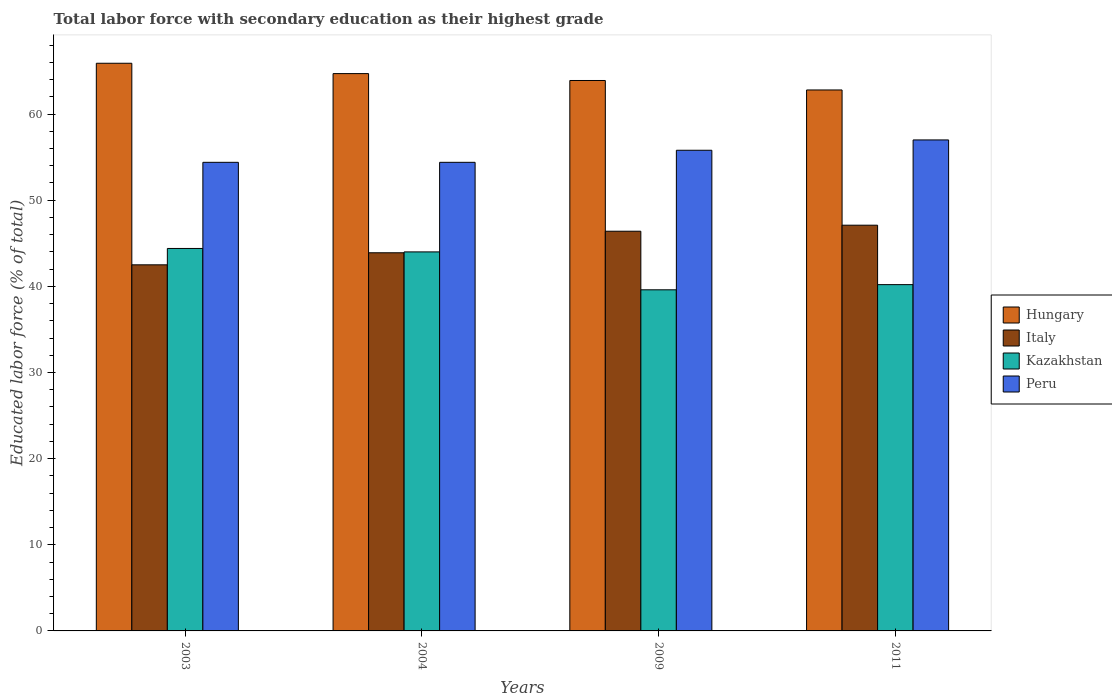How many different coloured bars are there?
Your response must be concise. 4. Are the number of bars on each tick of the X-axis equal?
Provide a short and direct response. Yes. How many bars are there on the 2nd tick from the right?
Your response must be concise. 4. What is the label of the 2nd group of bars from the left?
Your answer should be compact. 2004. What is the percentage of total labor force with primary education in Kazakhstan in 2009?
Your answer should be compact. 39.6. Across all years, what is the minimum percentage of total labor force with primary education in Peru?
Your response must be concise. 54.4. In which year was the percentage of total labor force with primary education in Peru maximum?
Your answer should be very brief. 2011. In which year was the percentage of total labor force with primary education in Italy minimum?
Make the answer very short. 2003. What is the total percentage of total labor force with primary education in Peru in the graph?
Make the answer very short. 221.6. What is the difference between the percentage of total labor force with primary education in Italy in 2004 and that in 2009?
Ensure brevity in your answer.  -2.5. What is the difference between the percentage of total labor force with primary education in Peru in 2011 and the percentage of total labor force with primary education in Hungary in 2003?
Your answer should be very brief. -8.9. What is the average percentage of total labor force with primary education in Peru per year?
Your answer should be very brief. 55.4. In how many years, is the percentage of total labor force with primary education in Peru greater than 32 %?
Provide a succinct answer. 4. What is the ratio of the percentage of total labor force with primary education in Italy in 2003 to that in 2011?
Your response must be concise. 0.9. Is the percentage of total labor force with primary education in Italy in 2003 less than that in 2011?
Your answer should be compact. Yes. What is the difference between the highest and the second highest percentage of total labor force with primary education in Italy?
Offer a terse response. 0.7. What is the difference between the highest and the lowest percentage of total labor force with primary education in Peru?
Your answer should be compact. 2.6. Is it the case that in every year, the sum of the percentage of total labor force with primary education in Hungary and percentage of total labor force with primary education in Kazakhstan is greater than the sum of percentage of total labor force with primary education in Peru and percentage of total labor force with primary education in Italy?
Make the answer very short. Yes. What does the 1st bar from the left in 2009 represents?
Your answer should be compact. Hungary. What does the 2nd bar from the right in 2003 represents?
Keep it short and to the point. Kazakhstan. Are all the bars in the graph horizontal?
Provide a short and direct response. No. How many years are there in the graph?
Keep it short and to the point. 4. Are the values on the major ticks of Y-axis written in scientific E-notation?
Keep it short and to the point. No. Where does the legend appear in the graph?
Give a very brief answer. Center right. How many legend labels are there?
Keep it short and to the point. 4. How are the legend labels stacked?
Your response must be concise. Vertical. What is the title of the graph?
Keep it short and to the point. Total labor force with secondary education as their highest grade. What is the label or title of the Y-axis?
Keep it short and to the point. Educated labor force (% of total). What is the Educated labor force (% of total) in Hungary in 2003?
Your answer should be very brief. 65.9. What is the Educated labor force (% of total) in Italy in 2003?
Offer a terse response. 42.5. What is the Educated labor force (% of total) of Kazakhstan in 2003?
Your response must be concise. 44.4. What is the Educated labor force (% of total) of Peru in 2003?
Your answer should be compact. 54.4. What is the Educated labor force (% of total) in Hungary in 2004?
Offer a very short reply. 64.7. What is the Educated labor force (% of total) of Italy in 2004?
Provide a short and direct response. 43.9. What is the Educated labor force (% of total) in Peru in 2004?
Your answer should be compact. 54.4. What is the Educated labor force (% of total) of Hungary in 2009?
Provide a succinct answer. 63.9. What is the Educated labor force (% of total) in Italy in 2009?
Ensure brevity in your answer.  46.4. What is the Educated labor force (% of total) in Kazakhstan in 2009?
Keep it short and to the point. 39.6. What is the Educated labor force (% of total) in Peru in 2009?
Ensure brevity in your answer.  55.8. What is the Educated labor force (% of total) in Hungary in 2011?
Keep it short and to the point. 62.8. What is the Educated labor force (% of total) of Italy in 2011?
Give a very brief answer. 47.1. What is the Educated labor force (% of total) of Kazakhstan in 2011?
Your response must be concise. 40.2. What is the Educated labor force (% of total) of Peru in 2011?
Your response must be concise. 57. Across all years, what is the maximum Educated labor force (% of total) in Hungary?
Offer a very short reply. 65.9. Across all years, what is the maximum Educated labor force (% of total) in Italy?
Your answer should be very brief. 47.1. Across all years, what is the maximum Educated labor force (% of total) in Kazakhstan?
Your answer should be compact. 44.4. Across all years, what is the minimum Educated labor force (% of total) in Hungary?
Ensure brevity in your answer.  62.8. Across all years, what is the minimum Educated labor force (% of total) in Italy?
Give a very brief answer. 42.5. Across all years, what is the minimum Educated labor force (% of total) in Kazakhstan?
Your answer should be very brief. 39.6. Across all years, what is the minimum Educated labor force (% of total) in Peru?
Your answer should be compact. 54.4. What is the total Educated labor force (% of total) in Hungary in the graph?
Ensure brevity in your answer.  257.3. What is the total Educated labor force (% of total) of Italy in the graph?
Make the answer very short. 179.9. What is the total Educated labor force (% of total) of Kazakhstan in the graph?
Offer a very short reply. 168.2. What is the total Educated labor force (% of total) in Peru in the graph?
Offer a terse response. 221.6. What is the difference between the Educated labor force (% of total) in Hungary in 2003 and that in 2004?
Provide a succinct answer. 1.2. What is the difference between the Educated labor force (% of total) in Italy in 2003 and that in 2004?
Provide a succinct answer. -1.4. What is the difference between the Educated labor force (% of total) of Kazakhstan in 2003 and that in 2004?
Give a very brief answer. 0.4. What is the difference between the Educated labor force (% of total) of Hungary in 2003 and that in 2009?
Make the answer very short. 2. What is the difference between the Educated labor force (% of total) in Italy in 2003 and that in 2009?
Your response must be concise. -3.9. What is the difference between the Educated labor force (% of total) of Peru in 2003 and that in 2009?
Your response must be concise. -1.4. What is the difference between the Educated labor force (% of total) of Hungary in 2003 and that in 2011?
Offer a terse response. 3.1. What is the difference between the Educated labor force (% of total) in Hungary in 2004 and that in 2009?
Offer a terse response. 0.8. What is the difference between the Educated labor force (% of total) of Kazakhstan in 2004 and that in 2009?
Give a very brief answer. 4.4. What is the difference between the Educated labor force (% of total) of Hungary in 2004 and that in 2011?
Offer a terse response. 1.9. What is the difference between the Educated labor force (% of total) in Italy in 2004 and that in 2011?
Ensure brevity in your answer.  -3.2. What is the difference between the Educated labor force (% of total) of Kazakhstan in 2004 and that in 2011?
Give a very brief answer. 3.8. What is the difference between the Educated labor force (% of total) in Hungary in 2009 and that in 2011?
Ensure brevity in your answer.  1.1. What is the difference between the Educated labor force (% of total) in Kazakhstan in 2009 and that in 2011?
Your answer should be very brief. -0.6. What is the difference between the Educated labor force (% of total) in Hungary in 2003 and the Educated labor force (% of total) in Italy in 2004?
Offer a very short reply. 22. What is the difference between the Educated labor force (% of total) of Hungary in 2003 and the Educated labor force (% of total) of Kazakhstan in 2004?
Your response must be concise. 21.9. What is the difference between the Educated labor force (% of total) in Hungary in 2003 and the Educated labor force (% of total) in Peru in 2004?
Offer a terse response. 11.5. What is the difference between the Educated labor force (% of total) in Italy in 2003 and the Educated labor force (% of total) in Peru in 2004?
Offer a terse response. -11.9. What is the difference between the Educated labor force (% of total) of Hungary in 2003 and the Educated labor force (% of total) of Kazakhstan in 2009?
Ensure brevity in your answer.  26.3. What is the difference between the Educated labor force (% of total) in Hungary in 2003 and the Educated labor force (% of total) in Peru in 2009?
Ensure brevity in your answer.  10.1. What is the difference between the Educated labor force (% of total) of Italy in 2003 and the Educated labor force (% of total) of Kazakhstan in 2009?
Provide a succinct answer. 2.9. What is the difference between the Educated labor force (% of total) of Kazakhstan in 2003 and the Educated labor force (% of total) of Peru in 2009?
Ensure brevity in your answer.  -11.4. What is the difference between the Educated labor force (% of total) of Hungary in 2003 and the Educated labor force (% of total) of Italy in 2011?
Your answer should be compact. 18.8. What is the difference between the Educated labor force (% of total) in Hungary in 2003 and the Educated labor force (% of total) in Kazakhstan in 2011?
Make the answer very short. 25.7. What is the difference between the Educated labor force (% of total) in Hungary in 2003 and the Educated labor force (% of total) in Peru in 2011?
Give a very brief answer. 8.9. What is the difference between the Educated labor force (% of total) in Hungary in 2004 and the Educated labor force (% of total) in Italy in 2009?
Make the answer very short. 18.3. What is the difference between the Educated labor force (% of total) in Hungary in 2004 and the Educated labor force (% of total) in Kazakhstan in 2009?
Your answer should be compact. 25.1. What is the difference between the Educated labor force (% of total) of Italy in 2004 and the Educated labor force (% of total) of Kazakhstan in 2009?
Keep it short and to the point. 4.3. What is the difference between the Educated labor force (% of total) of Italy in 2004 and the Educated labor force (% of total) of Peru in 2009?
Your answer should be compact. -11.9. What is the difference between the Educated labor force (% of total) of Kazakhstan in 2004 and the Educated labor force (% of total) of Peru in 2009?
Provide a short and direct response. -11.8. What is the difference between the Educated labor force (% of total) in Hungary in 2004 and the Educated labor force (% of total) in Italy in 2011?
Your answer should be compact. 17.6. What is the difference between the Educated labor force (% of total) in Italy in 2004 and the Educated labor force (% of total) in Kazakhstan in 2011?
Your answer should be compact. 3.7. What is the difference between the Educated labor force (% of total) of Italy in 2004 and the Educated labor force (% of total) of Peru in 2011?
Keep it short and to the point. -13.1. What is the difference between the Educated labor force (% of total) in Hungary in 2009 and the Educated labor force (% of total) in Kazakhstan in 2011?
Your answer should be very brief. 23.7. What is the difference between the Educated labor force (% of total) in Hungary in 2009 and the Educated labor force (% of total) in Peru in 2011?
Your answer should be compact. 6.9. What is the difference between the Educated labor force (% of total) of Kazakhstan in 2009 and the Educated labor force (% of total) of Peru in 2011?
Offer a terse response. -17.4. What is the average Educated labor force (% of total) of Hungary per year?
Your answer should be compact. 64.33. What is the average Educated labor force (% of total) in Italy per year?
Offer a terse response. 44.98. What is the average Educated labor force (% of total) of Kazakhstan per year?
Offer a very short reply. 42.05. What is the average Educated labor force (% of total) in Peru per year?
Your answer should be very brief. 55.4. In the year 2003, what is the difference between the Educated labor force (% of total) in Hungary and Educated labor force (% of total) in Italy?
Provide a short and direct response. 23.4. In the year 2003, what is the difference between the Educated labor force (% of total) in Hungary and Educated labor force (% of total) in Kazakhstan?
Provide a succinct answer. 21.5. In the year 2003, what is the difference between the Educated labor force (% of total) in Hungary and Educated labor force (% of total) in Peru?
Keep it short and to the point. 11.5. In the year 2003, what is the difference between the Educated labor force (% of total) of Italy and Educated labor force (% of total) of Kazakhstan?
Make the answer very short. -1.9. In the year 2003, what is the difference between the Educated labor force (% of total) of Italy and Educated labor force (% of total) of Peru?
Make the answer very short. -11.9. In the year 2003, what is the difference between the Educated labor force (% of total) in Kazakhstan and Educated labor force (% of total) in Peru?
Give a very brief answer. -10. In the year 2004, what is the difference between the Educated labor force (% of total) in Hungary and Educated labor force (% of total) in Italy?
Offer a very short reply. 20.8. In the year 2004, what is the difference between the Educated labor force (% of total) in Hungary and Educated labor force (% of total) in Kazakhstan?
Your response must be concise. 20.7. In the year 2004, what is the difference between the Educated labor force (% of total) in Hungary and Educated labor force (% of total) in Peru?
Provide a short and direct response. 10.3. In the year 2004, what is the difference between the Educated labor force (% of total) in Italy and Educated labor force (% of total) in Kazakhstan?
Keep it short and to the point. -0.1. In the year 2004, what is the difference between the Educated labor force (% of total) of Italy and Educated labor force (% of total) of Peru?
Your response must be concise. -10.5. In the year 2004, what is the difference between the Educated labor force (% of total) in Kazakhstan and Educated labor force (% of total) in Peru?
Keep it short and to the point. -10.4. In the year 2009, what is the difference between the Educated labor force (% of total) of Hungary and Educated labor force (% of total) of Italy?
Offer a very short reply. 17.5. In the year 2009, what is the difference between the Educated labor force (% of total) in Hungary and Educated labor force (% of total) in Kazakhstan?
Your response must be concise. 24.3. In the year 2009, what is the difference between the Educated labor force (% of total) in Hungary and Educated labor force (% of total) in Peru?
Provide a succinct answer. 8.1. In the year 2009, what is the difference between the Educated labor force (% of total) of Italy and Educated labor force (% of total) of Kazakhstan?
Make the answer very short. 6.8. In the year 2009, what is the difference between the Educated labor force (% of total) in Kazakhstan and Educated labor force (% of total) in Peru?
Offer a very short reply. -16.2. In the year 2011, what is the difference between the Educated labor force (% of total) in Hungary and Educated labor force (% of total) in Italy?
Keep it short and to the point. 15.7. In the year 2011, what is the difference between the Educated labor force (% of total) of Hungary and Educated labor force (% of total) of Kazakhstan?
Offer a terse response. 22.6. In the year 2011, what is the difference between the Educated labor force (% of total) in Kazakhstan and Educated labor force (% of total) in Peru?
Provide a short and direct response. -16.8. What is the ratio of the Educated labor force (% of total) of Hungary in 2003 to that in 2004?
Offer a terse response. 1.02. What is the ratio of the Educated labor force (% of total) of Italy in 2003 to that in 2004?
Make the answer very short. 0.97. What is the ratio of the Educated labor force (% of total) in Kazakhstan in 2003 to that in 2004?
Your answer should be compact. 1.01. What is the ratio of the Educated labor force (% of total) in Peru in 2003 to that in 2004?
Your response must be concise. 1. What is the ratio of the Educated labor force (% of total) of Hungary in 2003 to that in 2009?
Make the answer very short. 1.03. What is the ratio of the Educated labor force (% of total) in Italy in 2003 to that in 2009?
Provide a short and direct response. 0.92. What is the ratio of the Educated labor force (% of total) of Kazakhstan in 2003 to that in 2009?
Offer a very short reply. 1.12. What is the ratio of the Educated labor force (% of total) in Peru in 2003 to that in 2009?
Your response must be concise. 0.97. What is the ratio of the Educated labor force (% of total) in Hungary in 2003 to that in 2011?
Provide a succinct answer. 1.05. What is the ratio of the Educated labor force (% of total) in Italy in 2003 to that in 2011?
Ensure brevity in your answer.  0.9. What is the ratio of the Educated labor force (% of total) in Kazakhstan in 2003 to that in 2011?
Your response must be concise. 1.1. What is the ratio of the Educated labor force (% of total) in Peru in 2003 to that in 2011?
Offer a terse response. 0.95. What is the ratio of the Educated labor force (% of total) in Hungary in 2004 to that in 2009?
Make the answer very short. 1.01. What is the ratio of the Educated labor force (% of total) of Italy in 2004 to that in 2009?
Make the answer very short. 0.95. What is the ratio of the Educated labor force (% of total) in Peru in 2004 to that in 2009?
Offer a terse response. 0.97. What is the ratio of the Educated labor force (% of total) of Hungary in 2004 to that in 2011?
Provide a succinct answer. 1.03. What is the ratio of the Educated labor force (% of total) of Italy in 2004 to that in 2011?
Offer a very short reply. 0.93. What is the ratio of the Educated labor force (% of total) of Kazakhstan in 2004 to that in 2011?
Provide a short and direct response. 1.09. What is the ratio of the Educated labor force (% of total) of Peru in 2004 to that in 2011?
Keep it short and to the point. 0.95. What is the ratio of the Educated labor force (% of total) of Hungary in 2009 to that in 2011?
Provide a short and direct response. 1.02. What is the ratio of the Educated labor force (% of total) of Italy in 2009 to that in 2011?
Ensure brevity in your answer.  0.99. What is the ratio of the Educated labor force (% of total) in Kazakhstan in 2009 to that in 2011?
Your answer should be compact. 0.99. What is the ratio of the Educated labor force (% of total) of Peru in 2009 to that in 2011?
Keep it short and to the point. 0.98. What is the difference between the highest and the second highest Educated labor force (% of total) of Hungary?
Give a very brief answer. 1.2. What is the difference between the highest and the lowest Educated labor force (% of total) in Italy?
Your answer should be very brief. 4.6. What is the difference between the highest and the lowest Educated labor force (% of total) in Kazakhstan?
Your answer should be compact. 4.8. What is the difference between the highest and the lowest Educated labor force (% of total) of Peru?
Provide a short and direct response. 2.6. 